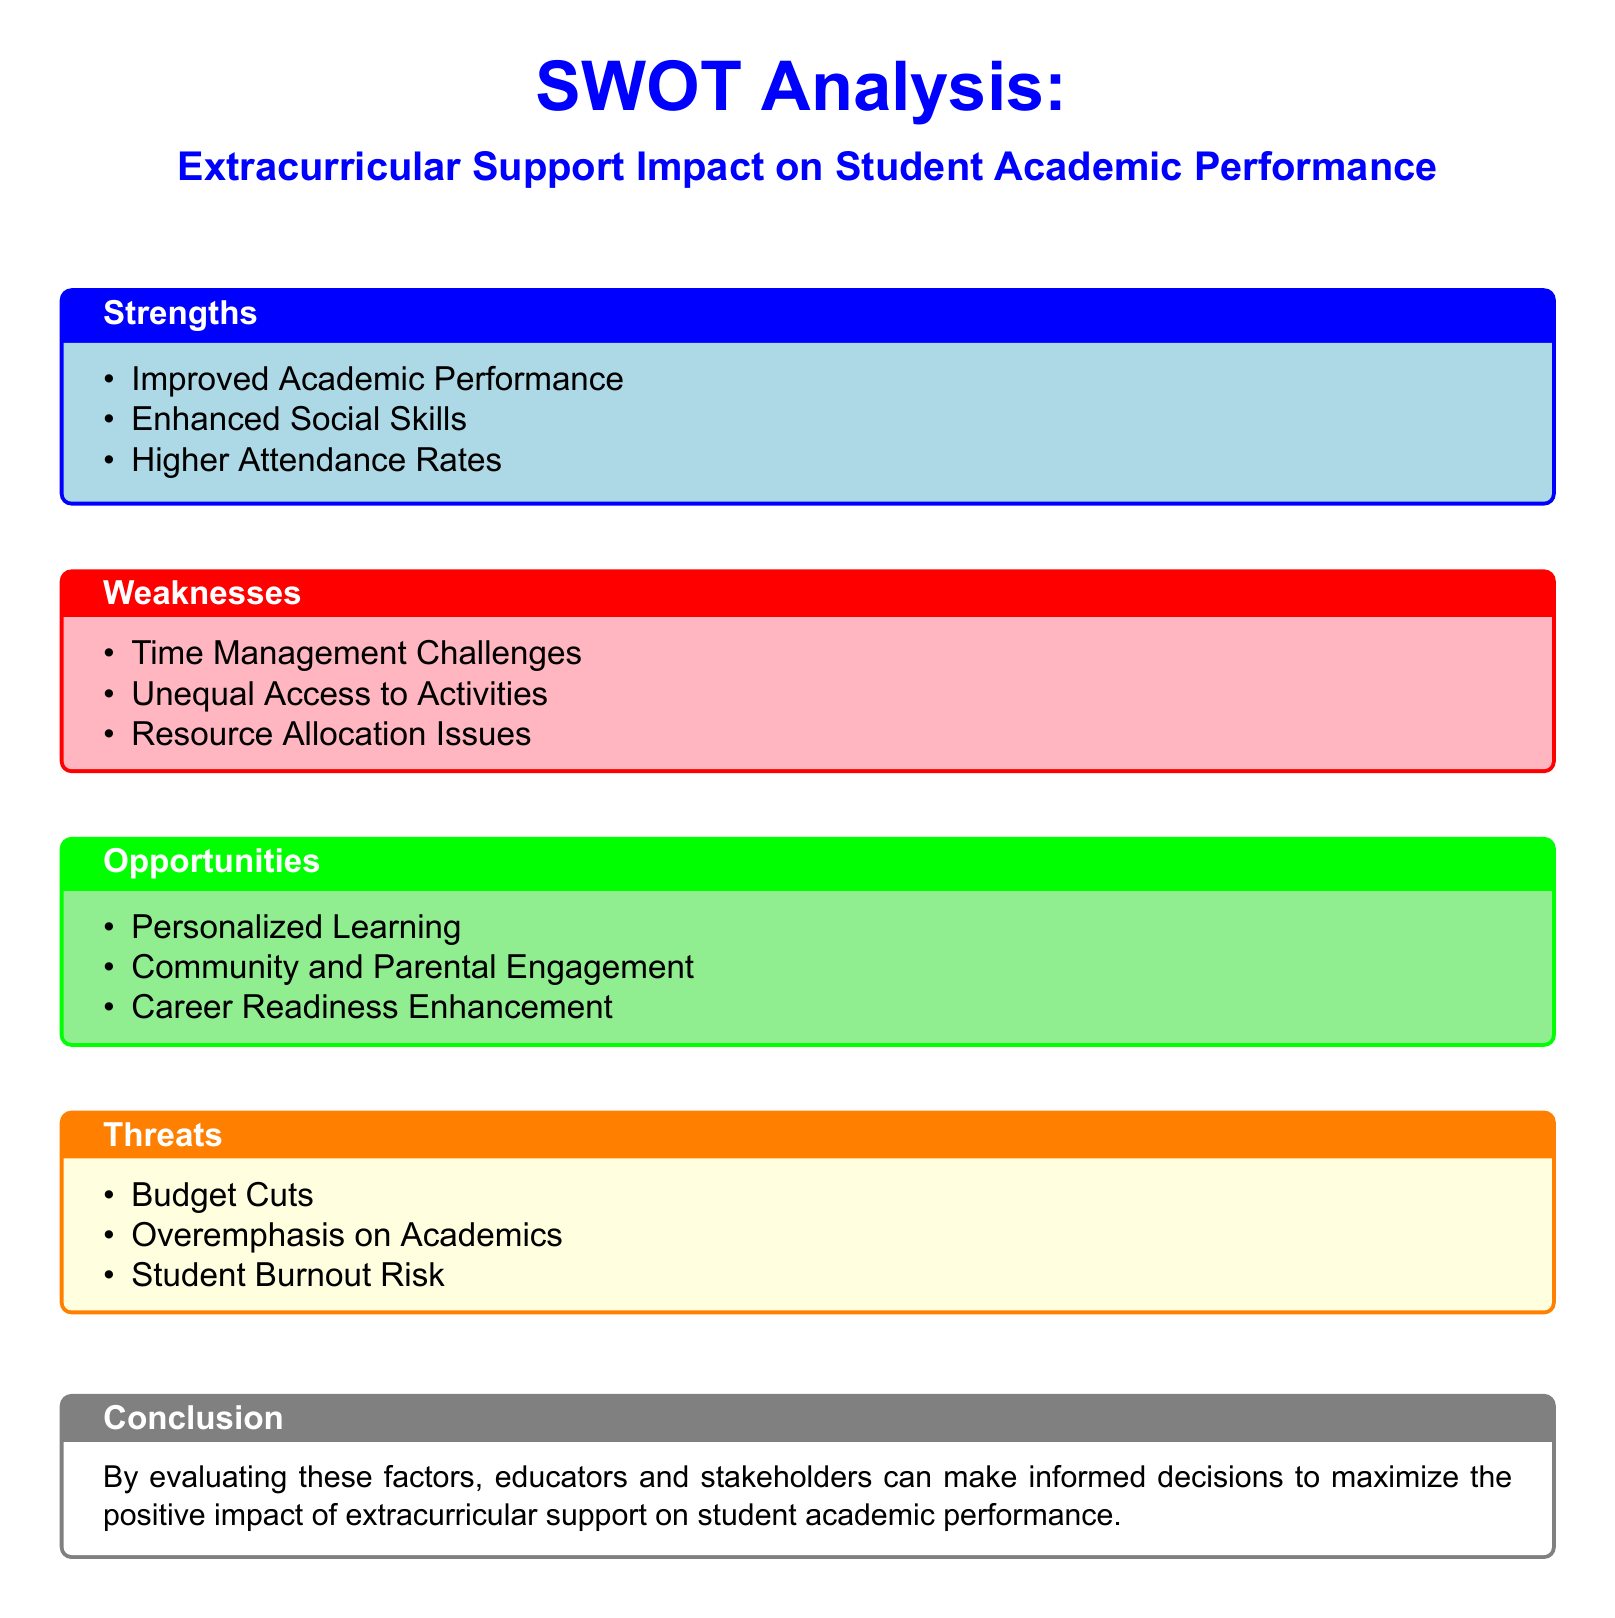What is the title of the SWOT analysis? The title of the SWOT analysis is presented at the top of the document, indicating the topic it covers.
Answer: Extracurricular Support Impact on Student Academic Performance How many strengths are listed in the document? The number of strengths is determined by counting the items in the Strengths section, which outlines positive aspects.
Answer: 3 What is one of the weaknesses identified? A weakness listed in the document highlights a challenge that may affect the positive impact of extracurricular activities on academics.
Answer: Time Management Challenges What opportunity relates to community involvement? An opportunity specifically mentions enhancing support from outside the school community, which could lead to better student engagement.
Answer: Community and Parental Engagement What threat is associated with financial issues? The threat category includes concerns regarding the funding for extracurricular activities which may impact their availability.
Answer: Budget Cuts Which item emphasizes enhancing student readiness for the future? An opportunity focuses on preparing students for their future careers, showcasing the broader purpose of extracurricular activities.
Answer: Career Readiness Enhancement How many threats are mentioned in the document? The total number of threats is counted from the Threats section, addressing concerns that may arise.
Answer: 3 What is the concluding message of the SWOT analysis? The conclusion summarizes the purpose of the SWOT analysis and suggests the importance of informed decision-making.
Answer: Maximize the positive impact of extracurricular support on student academic performance 